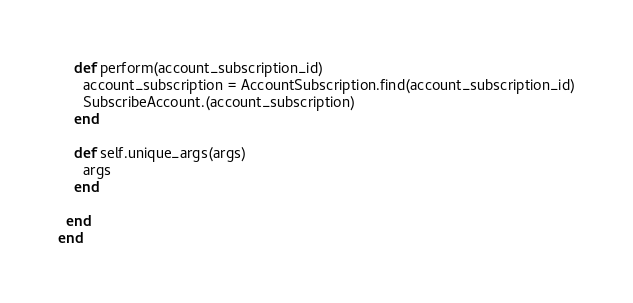Convert code to text. <code><loc_0><loc_0><loc_500><loc_500><_Ruby_>    def perform(account_subscription_id)
      account_subscription = AccountSubscription.find(account_subscription_id)
      SubscribeAccount.(account_subscription)
    end

    def self.unique_args(args)
      args
    end

  end
end
</code> 